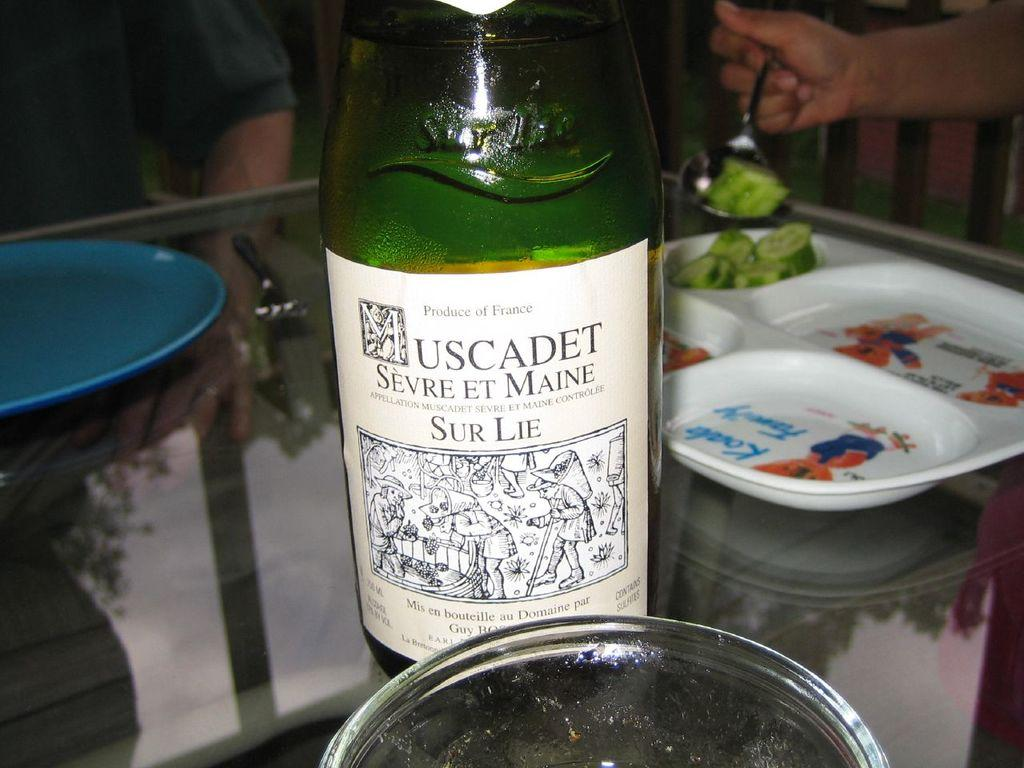<image>
Write a terse but informative summary of the picture. A bottle of Muscadet Sevre et maine on a table 